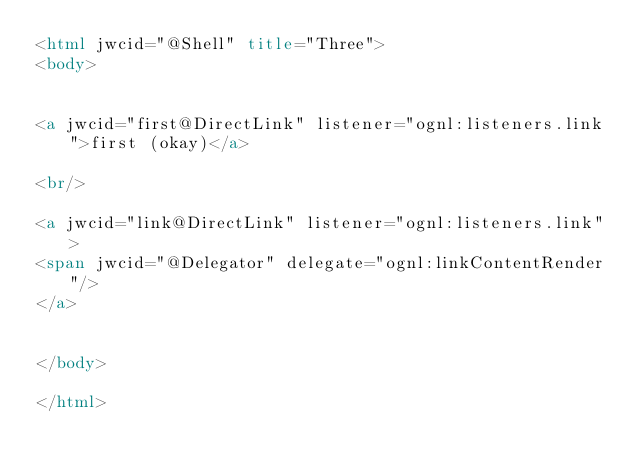<code> <loc_0><loc_0><loc_500><loc_500><_HTML_><html jwcid="@Shell" title="Three">
<body>
	

<a jwcid="first@DirectLink" listener="ognl:listeners.link">first (okay)</a>

<br/>

<a jwcid="link@DirectLink" listener="ognl:listeners.link">
<span jwcid="@Delegator" delegate="ognl:linkContentRender"/>	
</a>


</body>

</html></code> 